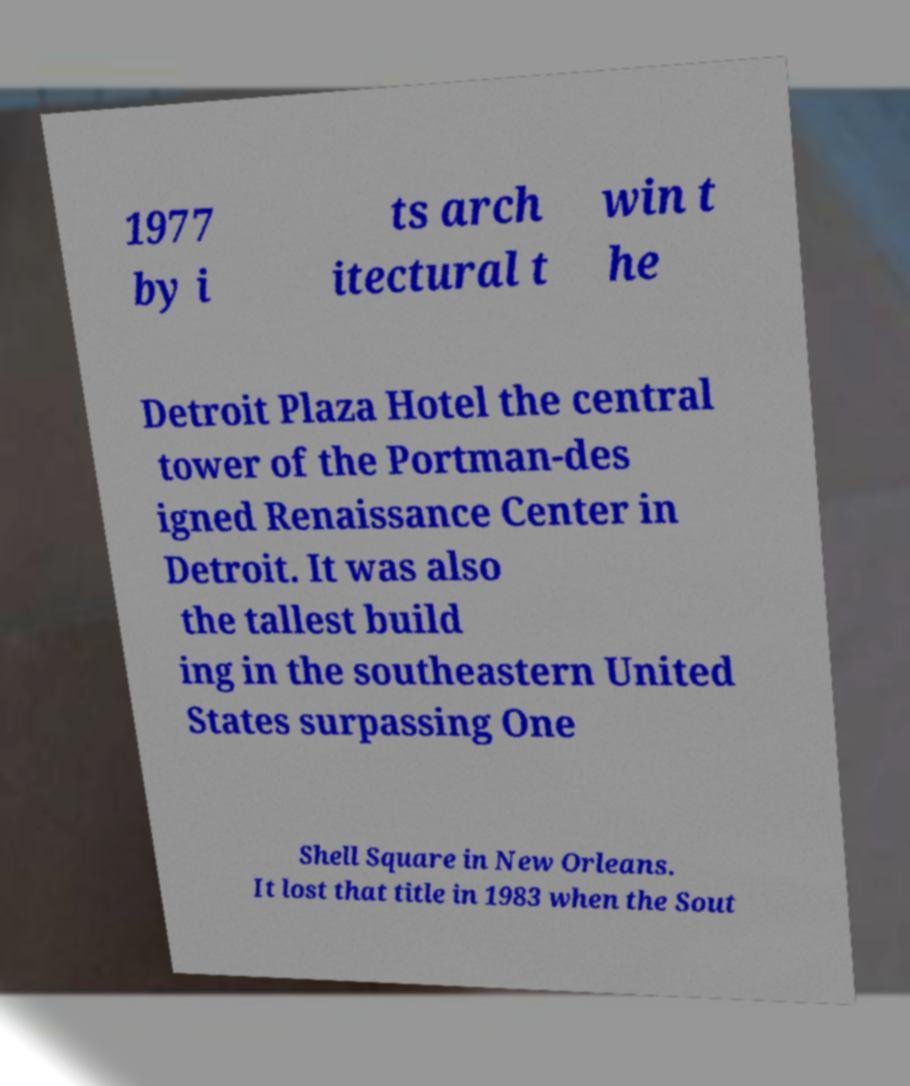There's text embedded in this image that I need extracted. Can you transcribe it verbatim? 1977 by i ts arch itectural t win t he Detroit Plaza Hotel the central tower of the Portman-des igned Renaissance Center in Detroit. It was also the tallest build ing in the southeastern United States surpassing One Shell Square in New Orleans. It lost that title in 1983 when the Sout 